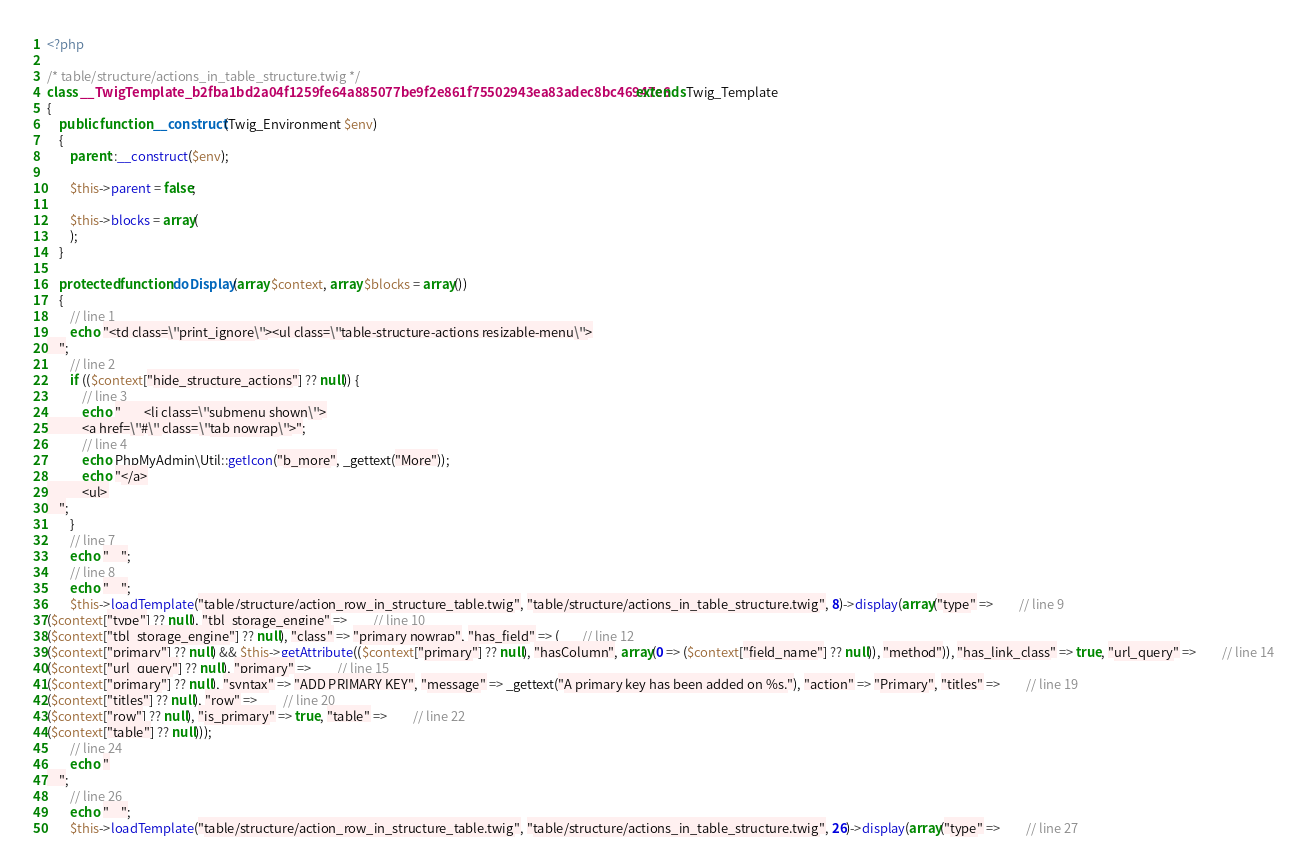<code> <loc_0><loc_0><loc_500><loc_500><_PHP_><?php

/* table/structure/actions_in_table_structure.twig */
class __TwigTemplate_b2fba1bd2a04f1259fe64a885077be9f2e861f75502943ea83adec8bc46947e6 extends Twig_Template
{
    public function __construct(Twig_Environment $env)
    {
        parent::__construct($env);

        $this->parent = false;

        $this->blocks = array(
        );
    }

    protected function doDisplay(array $context, array $blocks = array())
    {
        // line 1
        echo "<td class=\"print_ignore\"><ul class=\"table-structure-actions resizable-menu\">
    ";
        // line 2
        if (($context["hide_structure_actions"] ?? null)) {
            // line 3
            echo "        <li class=\"submenu shown\">
            <a href=\"#\" class=\"tab nowrap\">";
            // line 4
            echo PhpMyAdmin\Util::getIcon("b_more", _gettext("More"));
            echo "</a>
            <ul>
    ";
        }
        // line 7
        echo "    ";
        // line 8
        echo "    ";
        $this->loadTemplate("table/structure/action_row_in_structure_table.twig", "table/structure/actions_in_table_structure.twig", 8)->display(array("type" =>         // line 9
($context["type"] ?? null), "tbl_storage_engine" =>         // line 10
($context["tbl_storage_engine"] ?? null), "class" => "primary nowrap", "has_field" => (        // line 12
($context["primary"] ?? null) && $this->getAttribute(($context["primary"] ?? null), "hasColumn", array(0 => ($context["field_name"] ?? null)), "method")), "has_link_class" => true, "url_query" =>         // line 14
($context["url_query"] ?? null), "primary" =>         // line 15
($context["primary"] ?? null), "syntax" => "ADD PRIMARY KEY", "message" => _gettext("A primary key has been added on %s."), "action" => "Primary", "titles" =>         // line 19
($context["titles"] ?? null), "row" =>         // line 20
($context["row"] ?? null), "is_primary" => true, "table" =>         // line 22
($context["table"] ?? null)));
        // line 24
        echo "
    ";
        // line 26
        echo "    ";
        $this->loadTemplate("table/structure/action_row_in_structure_table.twig", "table/structure/actions_in_table_structure.twig", 26)->display(array("type" =>         // line 27</code> 